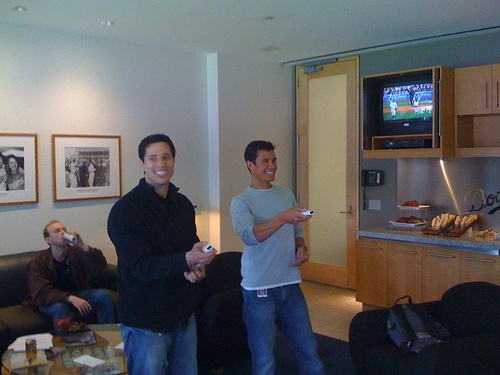Describe the objects in this image and their specific colors. I can see people in darkgray, black, navy, and gray tones, people in darkgray, navy, gray, and black tones, couch in darkgray, black, navy, maroon, and gray tones, people in darkgray, black, gray, and navy tones, and tv in darkgray, black, navy, gray, and lightblue tones in this image. 